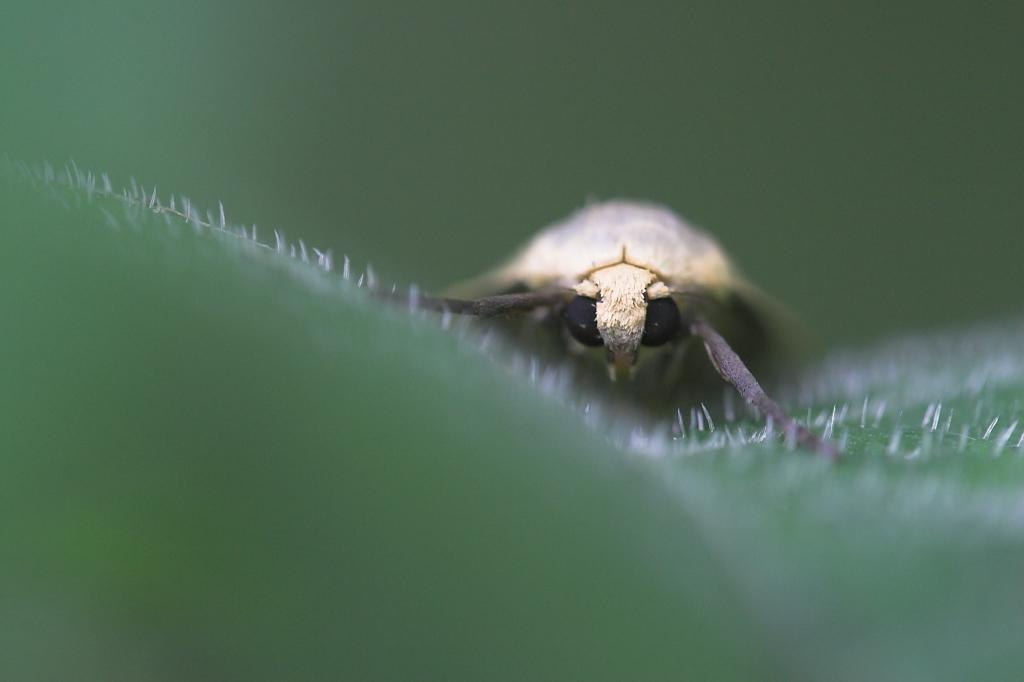What type of creature is present in the image? There is an insect in the image. What is the insect resting on? The insect is on a green surface. Can you describe the background of the image? The background of the image is blurred. What type of health advice can be seen on the dolls in the image? There are no dolls present in the image, and therefore no health advice can be seen on them. 